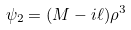Convert formula to latex. <formula><loc_0><loc_0><loc_500><loc_500>\psi _ { 2 } = ( M - i \ell ) \rho ^ { 3 }</formula> 